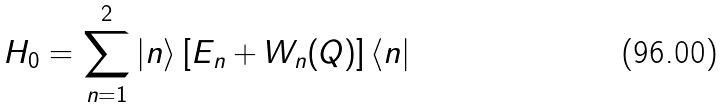<formula> <loc_0><loc_0><loc_500><loc_500>H _ { 0 } = \sum _ { n = 1 } ^ { 2 } | n \rangle \left [ E _ { n } + W _ { n } ( Q ) \right ] \langle n |</formula> 